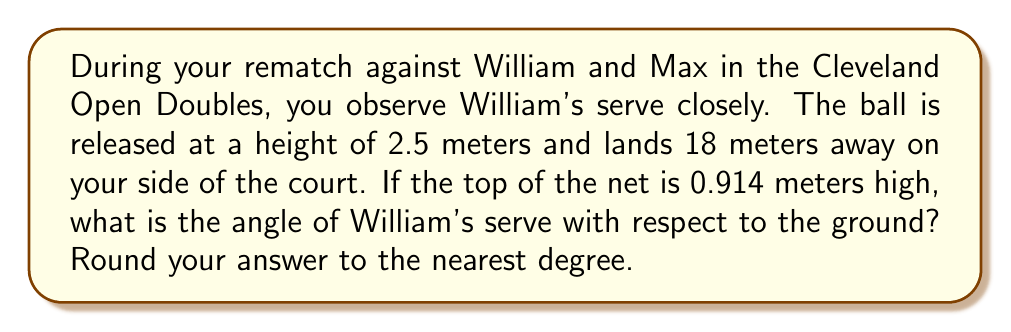What is the answer to this math problem? Let's approach this step-by-step using trigonometry:

1) First, let's visualize the problem:

[asy]
import geometry;

size(200);
pair A = (0,0), B = (18,0), C = (0,2.5), D = (0,0.914);
draw(A--B--C--A);
draw(A--D,dashed);
label("2.5m", C, W);
label("18m", (9,0), S);
label("0.914m", D, W);
label("θ", (1,0.5), NE);
[/asy]

2) We need to find the angle θ between the serve trajectory and the ground.

3) We can use the tangent function, which is opposite over adjacent:

   $$\tan(\theta) = \frac{\text{opposite}}{\text{adjacent}}$$

4) The opposite side is the difference in height between the release point and the net:
   
   $$\text{opposite} = 2.5 - 0.914 = 1.586 \text{ meters}$$

5) The adjacent side is the horizontal distance to the net. We don't know this exactly, but we can assume it's about half the total distance:

   $$\text{adjacent} \approx \frac{18}{2} = 9 \text{ meters}$$

6) Now we can calculate the tangent:

   $$\tan(\theta) = \frac{1.586}{9} \approx 0.1762$$

7) To find θ, we need to use the inverse tangent (arctan or tan^(-1)):

   $$\theta = \tan^{-1}(0.1762) \approx 9.99°$$

8) Rounding to the nearest degree:

   $$\theta \approx 10°$$
Answer: $10°$ 